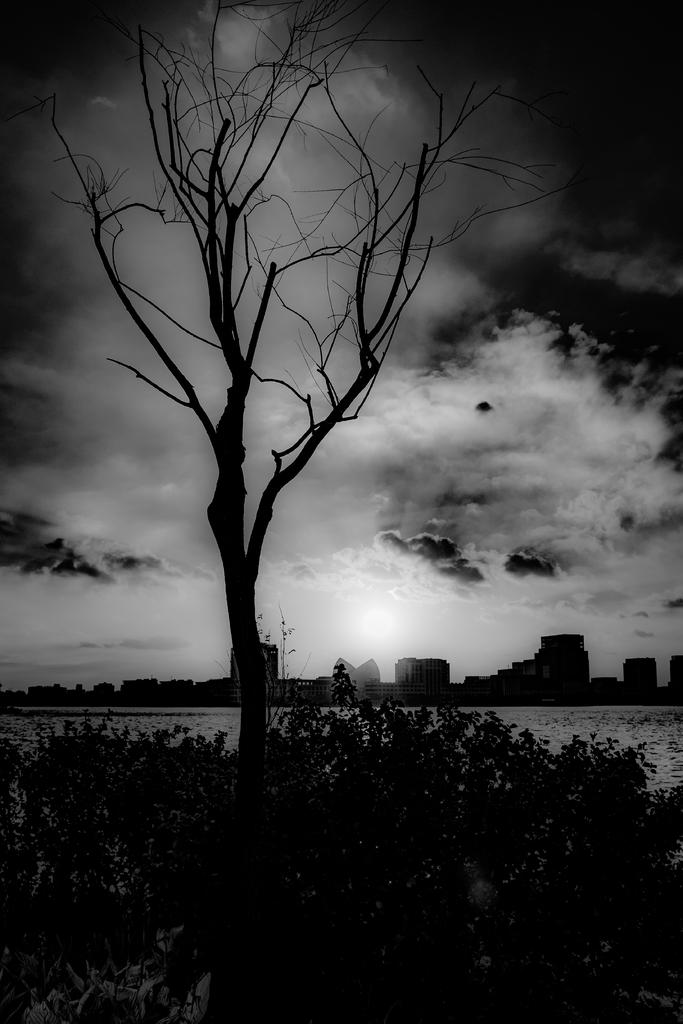What is the color scheme of the image? The image is in black and white. What type of vegetation can be seen in the image? There are plants and a tree in the image. What is the water feature in the image? There is water visible in the image. What can be seen in the background of the image? There are buildings in the background of the image. What is visible at the top of the image? The sky is visible at the top of the image. What type of wing is visible on the tree in the image? There are no wings visible on the tree in the image. What type of educational institution can be seen in the image? There is no educational institution present in the image. 